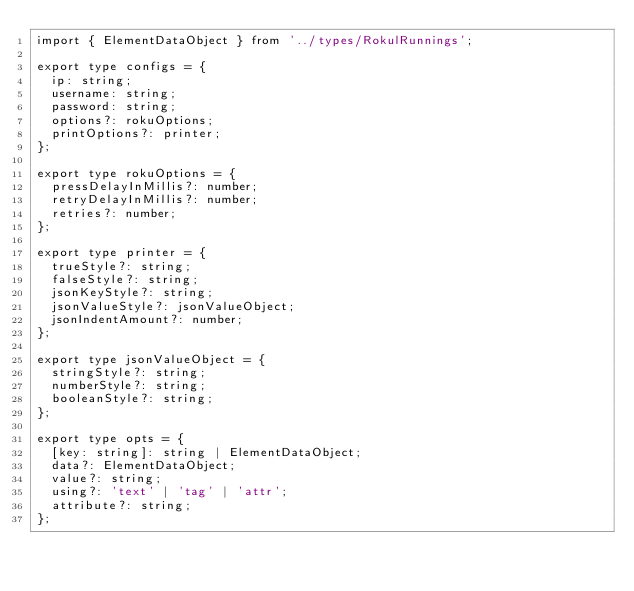Convert code to text. <code><loc_0><loc_0><loc_500><loc_500><_TypeScript_>import { ElementDataObject } from '../types/RokulRunnings';

export type configs = {
  ip: string;
  username: string;
  password: string;
  options?: rokuOptions;
  printOptions?: printer;
};

export type rokuOptions = {
  pressDelayInMillis?: number;
  retryDelayInMillis?: number;
  retries?: number;
};

export type printer = {
  trueStyle?: string;
  falseStyle?: string;
  jsonKeyStyle?: string;
  jsonValueStyle?: jsonValueObject;
  jsonIndentAmount?: number;
};

export type jsonValueObject = {
  stringStyle?: string;
  numberStyle?: string;
  booleanStyle?: string;
};

export type opts = {
  [key: string]: string | ElementDataObject;
  data?: ElementDataObject;
  value?: string;
  using?: 'text' | 'tag' | 'attr';
  attribute?: string;
};
</code> 